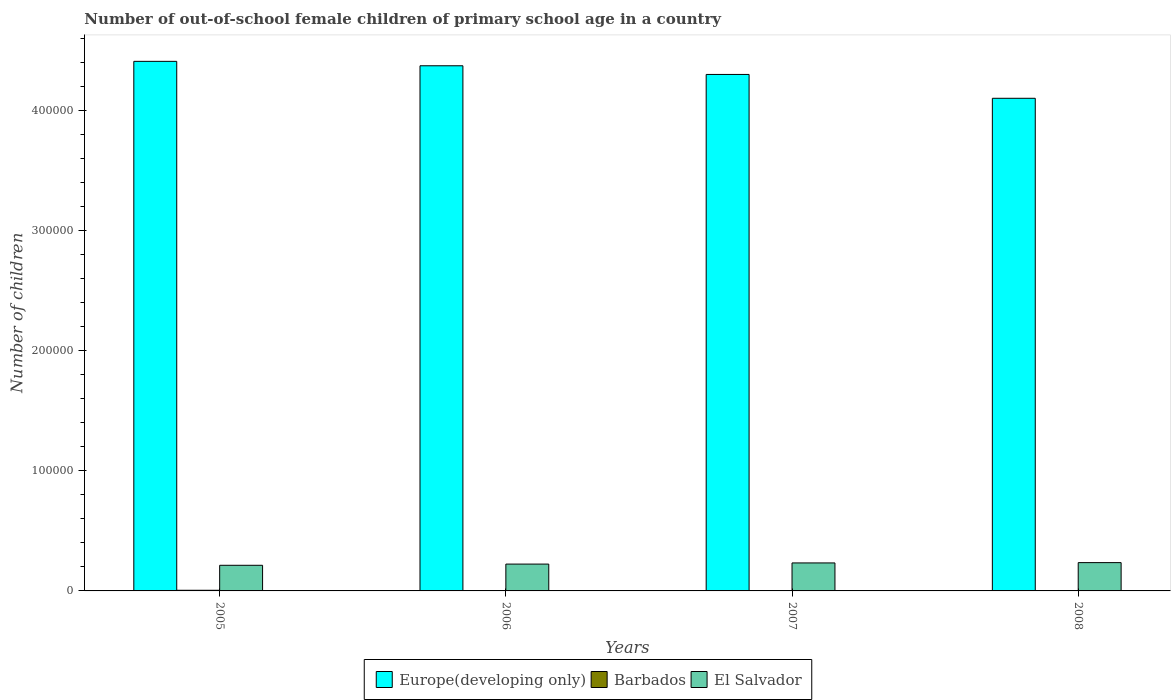How many different coloured bars are there?
Offer a very short reply. 3. What is the number of out-of-school female children in Europe(developing only) in 2008?
Ensure brevity in your answer.  4.11e+05. Across all years, what is the maximum number of out-of-school female children in El Salvador?
Ensure brevity in your answer.  2.36e+04. Across all years, what is the minimum number of out-of-school female children in Europe(developing only)?
Keep it short and to the point. 4.11e+05. In which year was the number of out-of-school female children in Barbados minimum?
Provide a short and direct response. 2008. What is the total number of out-of-school female children in Europe(developing only) in the graph?
Offer a very short reply. 1.72e+06. What is the difference between the number of out-of-school female children in Europe(developing only) in 2006 and that in 2007?
Give a very brief answer. 7225. What is the difference between the number of out-of-school female children in Barbados in 2007 and the number of out-of-school female children in El Salvador in 2005?
Ensure brevity in your answer.  -2.11e+04. What is the average number of out-of-school female children in El Salvador per year?
Keep it short and to the point. 2.27e+04. In the year 2006, what is the difference between the number of out-of-school female children in Europe(developing only) and number of out-of-school female children in Barbados?
Keep it short and to the point. 4.37e+05. In how many years, is the number of out-of-school female children in Europe(developing only) greater than 320000?
Your answer should be compact. 4. What is the ratio of the number of out-of-school female children in Europe(developing only) in 2006 to that in 2007?
Provide a succinct answer. 1.02. Is the number of out-of-school female children in Barbados in 2005 less than that in 2008?
Keep it short and to the point. No. Is the difference between the number of out-of-school female children in Europe(developing only) in 2005 and 2007 greater than the difference between the number of out-of-school female children in Barbados in 2005 and 2007?
Your answer should be compact. Yes. What is the difference between the highest and the second highest number of out-of-school female children in Europe(developing only)?
Your response must be concise. 3679. What is the difference between the highest and the lowest number of out-of-school female children in Europe(developing only)?
Your answer should be very brief. 3.08e+04. What does the 3rd bar from the left in 2008 represents?
Provide a succinct answer. El Salvador. What does the 2nd bar from the right in 2007 represents?
Give a very brief answer. Barbados. Is it the case that in every year, the sum of the number of out-of-school female children in Barbados and number of out-of-school female children in El Salvador is greater than the number of out-of-school female children in Europe(developing only)?
Keep it short and to the point. No. How many bars are there?
Give a very brief answer. 12. How many years are there in the graph?
Your answer should be compact. 4. What is the difference between two consecutive major ticks on the Y-axis?
Your answer should be very brief. 1.00e+05. Does the graph contain any zero values?
Keep it short and to the point. No. Does the graph contain grids?
Ensure brevity in your answer.  No. Where does the legend appear in the graph?
Provide a short and direct response. Bottom center. What is the title of the graph?
Offer a very short reply. Number of out-of-school female children of primary school age in a country. Does "Middle East & North Africa (all income levels)" appear as one of the legend labels in the graph?
Ensure brevity in your answer.  No. What is the label or title of the X-axis?
Provide a short and direct response. Years. What is the label or title of the Y-axis?
Ensure brevity in your answer.  Number of children. What is the Number of children in Europe(developing only) in 2005?
Give a very brief answer. 4.41e+05. What is the Number of children in Barbados in 2005?
Your answer should be compact. 541. What is the Number of children of El Salvador in 2005?
Provide a short and direct response. 2.14e+04. What is the Number of children in Europe(developing only) in 2006?
Your answer should be compact. 4.38e+05. What is the Number of children in Barbados in 2006?
Offer a terse response. 327. What is the Number of children in El Salvador in 2006?
Your answer should be compact. 2.24e+04. What is the Number of children in Europe(developing only) in 2007?
Your response must be concise. 4.30e+05. What is the Number of children of Barbados in 2007?
Give a very brief answer. 263. What is the Number of children in El Salvador in 2007?
Your answer should be very brief. 2.33e+04. What is the Number of children in Europe(developing only) in 2008?
Provide a short and direct response. 4.11e+05. What is the Number of children of Barbados in 2008?
Offer a terse response. 219. What is the Number of children of El Salvador in 2008?
Give a very brief answer. 2.36e+04. Across all years, what is the maximum Number of children in Europe(developing only)?
Ensure brevity in your answer.  4.41e+05. Across all years, what is the maximum Number of children in Barbados?
Keep it short and to the point. 541. Across all years, what is the maximum Number of children in El Salvador?
Give a very brief answer. 2.36e+04. Across all years, what is the minimum Number of children of Europe(developing only)?
Keep it short and to the point. 4.11e+05. Across all years, what is the minimum Number of children of Barbados?
Provide a short and direct response. 219. Across all years, what is the minimum Number of children of El Salvador?
Provide a succinct answer. 2.14e+04. What is the total Number of children in Europe(developing only) in the graph?
Offer a very short reply. 1.72e+06. What is the total Number of children in Barbados in the graph?
Keep it short and to the point. 1350. What is the total Number of children of El Salvador in the graph?
Your answer should be compact. 9.06e+04. What is the difference between the Number of children of Europe(developing only) in 2005 and that in 2006?
Keep it short and to the point. 3679. What is the difference between the Number of children in Barbados in 2005 and that in 2006?
Offer a very short reply. 214. What is the difference between the Number of children in El Salvador in 2005 and that in 2006?
Give a very brief answer. -1004. What is the difference between the Number of children of Europe(developing only) in 2005 and that in 2007?
Your answer should be compact. 1.09e+04. What is the difference between the Number of children in Barbados in 2005 and that in 2007?
Ensure brevity in your answer.  278. What is the difference between the Number of children in El Salvador in 2005 and that in 2007?
Make the answer very short. -1972. What is the difference between the Number of children in Europe(developing only) in 2005 and that in 2008?
Your answer should be very brief. 3.08e+04. What is the difference between the Number of children of Barbados in 2005 and that in 2008?
Ensure brevity in your answer.  322. What is the difference between the Number of children of El Salvador in 2005 and that in 2008?
Make the answer very short. -2230. What is the difference between the Number of children in Europe(developing only) in 2006 and that in 2007?
Offer a very short reply. 7225. What is the difference between the Number of children in Barbados in 2006 and that in 2007?
Ensure brevity in your answer.  64. What is the difference between the Number of children of El Salvador in 2006 and that in 2007?
Give a very brief answer. -968. What is the difference between the Number of children in Europe(developing only) in 2006 and that in 2008?
Your response must be concise. 2.71e+04. What is the difference between the Number of children in Barbados in 2006 and that in 2008?
Offer a terse response. 108. What is the difference between the Number of children of El Salvador in 2006 and that in 2008?
Your response must be concise. -1226. What is the difference between the Number of children of Europe(developing only) in 2007 and that in 2008?
Provide a succinct answer. 1.99e+04. What is the difference between the Number of children of Barbados in 2007 and that in 2008?
Your answer should be very brief. 44. What is the difference between the Number of children in El Salvador in 2007 and that in 2008?
Your answer should be very brief. -258. What is the difference between the Number of children in Europe(developing only) in 2005 and the Number of children in Barbados in 2006?
Provide a succinct answer. 4.41e+05. What is the difference between the Number of children in Europe(developing only) in 2005 and the Number of children in El Salvador in 2006?
Offer a terse response. 4.19e+05. What is the difference between the Number of children in Barbados in 2005 and the Number of children in El Salvador in 2006?
Your answer should be very brief. -2.18e+04. What is the difference between the Number of children of Europe(developing only) in 2005 and the Number of children of Barbados in 2007?
Provide a succinct answer. 4.41e+05. What is the difference between the Number of children in Europe(developing only) in 2005 and the Number of children in El Salvador in 2007?
Provide a short and direct response. 4.18e+05. What is the difference between the Number of children of Barbados in 2005 and the Number of children of El Salvador in 2007?
Make the answer very short. -2.28e+04. What is the difference between the Number of children of Europe(developing only) in 2005 and the Number of children of Barbados in 2008?
Provide a short and direct response. 4.41e+05. What is the difference between the Number of children of Europe(developing only) in 2005 and the Number of children of El Salvador in 2008?
Your response must be concise. 4.18e+05. What is the difference between the Number of children in Barbados in 2005 and the Number of children in El Salvador in 2008?
Offer a terse response. -2.30e+04. What is the difference between the Number of children in Europe(developing only) in 2006 and the Number of children in Barbados in 2007?
Keep it short and to the point. 4.37e+05. What is the difference between the Number of children in Europe(developing only) in 2006 and the Number of children in El Salvador in 2007?
Keep it short and to the point. 4.14e+05. What is the difference between the Number of children in Barbados in 2006 and the Number of children in El Salvador in 2007?
Your answer should be very brief. -2.30e+04. What is the difference between the Number of children in Europe(developing only) in 2006 and the Number of children in Barbados in 2008?
Keep it short and to the point. 4.37e+05. What is the difference between the Number of children of Europe(developing only) in 2006 and the Number of children of El Salvador in 2008?
Ensure brevity in your answer.  4.14e+05. What is the difference between the Number of children of Barbados in 2006 and the Number of children of El Salvador in 2008?
Give a very brief answer. -2.33e+04. What is the difference between the Number of children of Europe(developing only) in 2007 and the Number of children of Barbados in 2008?
Provide a succinct answer. 4.30e+05. What is the difference between the Number of children of Europe(developing only) in 2007 and the Number of children of El Salvador in 2008?
Ensure brevity in your answer.  4.07e+05. What is the difference between the Number of children of Barbados in 2007 and the Number of children of El Salvador in 2008?
Provide a succinct answer. -2.33e+04. What is the average Number of children in Europe(developing only) per year?
Provide a succinct answer. 4.30e+05. What is the average Number of children in Barbados per year?
Make the answer very short. 337.5. What is the average Number of children of El Salvador per year?
Offer a very short reply. 2.27e+04. In the year 2005, what is the difference between the Number of children of Europe(developing only) and Number of children of Barbados?
Offer a very short reply. 4.41e+05. In the year 2005, what is the difference between the Number of children in Europe(developing only) and Number of children in El Salvador?
Make the answer very short. 4.20e+05. In the year 2005, what is the difference between the Number of children in Barbados and Number of children in El Salvador?
Provide a short and direct response. -2.08e+04. In the year 2006, what is the difference between the Number of children of Europe(developing only) and Number of children of Barbados?
Your answer should be very brief. 4.37e+05. In the year 2006, what is the difference between the Number of children of Europe(developing only) and Number of children of El Salvador?
Provide a succinct answer. 4.15e+05. In the year 2006, what is the difference between the Number of children in Barbados and Number of children in El Salvador?
Your answer should be compact. -2.20e+04. In the year 2007, what is the difference between the Number of children in Europe(developing only) and Number of children in Barbados?
Ensure brevity in your answer.  4.30e+05. In the year 2007, what is the difference between the Number of children of Europe(developing only) and Number of children of El Salvador?
Your answer should be compact. 4.07e+05. In the year 2007, what is the difference between the Number of children in Barbados and Number of children in El Salvador?
Keep it short and to the point. -2.31e+04. In the year 2008, what is the difference between the Number of children of Europe(developing only) and Number of children of Barbados?
Keep it short and to the point. 4.10e+05. In the year 2008, what is the difference between the Number of children of Europe(developing only) and Number of children of El Salvador?
Ensure brevity in your answer.  3.87e+05. In the year 2008, what is the difference between the Number of children of Barbados and Number of children of El Salvador?
Ensure brevity in your answer.  -2.34e+04. What is the ratio of the Number of children in Europe(developing only) in 2005 to that in 2006?
Offer a very short reply. 1.01. What is the ratio of the Number of children in Barbados in 2005 to that in 2006?
Your answer should be very brief. 1.65. What is the ratio of the Number of children of El Salvador in 2005 to that in 2006?
Your answer should be very brief. 0.96. What is the ratio of the Number of children in Europe(developing only) in 2005 to that in 2007?
Give a very brief answer. 1.03. What is the ratio of the Number of children in Barbados in 2005 to that in 2007?
Ensure brevity in your answer.  2.06. What is the ratio of the Number of children in El Salvador in 2005 to that in 2007?
Make the answer very short. 0.92. What is the ratio of the Number of children in Europe(developing only) in 2005 to that in 2008?
Give a very brief answer. 1.07. What is the ratio of the Number of children in Barbados in 2005 to that in 2008?
Your answer should be compact. 2.47. What is the ratio of the Number of children of El Salvador in 2005 to that in 2008?
Make the answer very short. 0.91. What is the ratio of the Number of children in Europe(developing only) in 2006 to that in 2007?
Provide a short and direct response. 1.02. What is the ratio of the Number of children in Barbados in 2006 to that in 2007?
Give a very brief answer. 1.24. What is the ratio of the Number of children in El Salvador in 2006 to that in 2007?
Ensure brevity in your answer.  0.96. What is the ratio of the Number of children in Europe(developing only) in 2006 to that in 2008?
Offer a very short reply. 1.07. What is the ratio of the Number of children in Barbados in 2006 to that in 2008?
Keep it short and to the point. 1.49. What is the ratio of the Number of children in El Salvador in 2006 to that in 2008?
Ensure brevity in your answer.  0.95. What is the ratio of the Number of children in Europe(developing only) in 2007 to that in 2008?
Offer a terse response. 1.05. What is the ratio of the Number of children in Barbados in 2007 to that in 2008?
Give a very brief answer. 1.2. What is the ratio of the Number of children in El Salvador in 2007 to that in 2008?
Your response must be concise. 0.99. What is the difference between the highest and the second highest Number of children of Europe(developing only)?
Provide a short and direct response. 3679. What is the difference between the highest and the second highest Number of children of Barbados?
Offer a very short reply. 214. What is the difference between the highest and the second highest Number of children in El Salvador?
Your answer should be compact. 258. What is the difference between the highest and the lowest Number of children of Europe(developing only)?
Your response must be concise. 3.08e+04. What is the difference between the highest and the lowest Number of children of Barbados?
Your answer should be very brief. 322. What is the difference between the highest and the lowest Number of children of El Salvador?
Make the answer very short. 2230. 